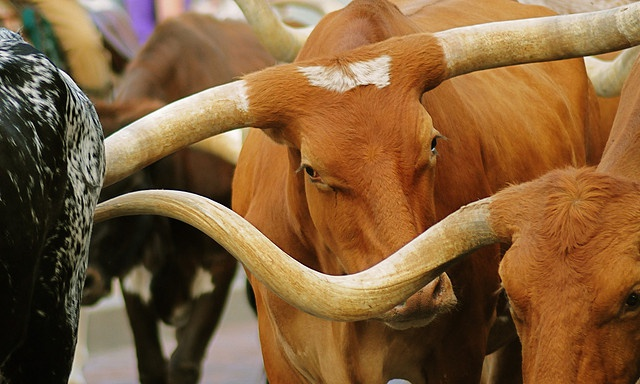Describe the objects in this image and their specific colors. I can see cow in olive, brown, maroon, tan, and black tones, cow in olive, brown, maroon, and tan tones, cow in olive, black, gray, darkgray, and darkgreen tones, and cow in olive, gray, brown, and maroon tones in this image. 